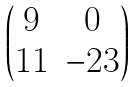<formula> <loc_0><loc_0><loc_500><loc_500>\begin{pmatrix} 9 & 0 \\ 1 1 & - 2 3 \end{pmatrix}</formula> 